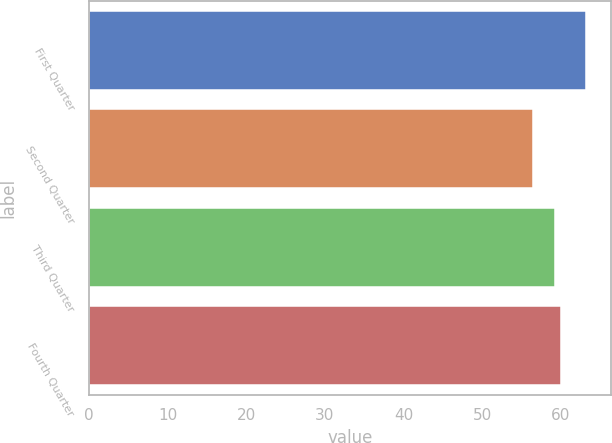<chart> <loc_0><loc_0><loc_500><loc_500><bar_chart><fcel>First Quarter<fcel>Second Quarter<fcel>Third Quarter<fcel>Fourth Quarter<nl><fcel>63.17<fcel>56.5<fcel>59.18<fcel>59.99<nl></chart> 